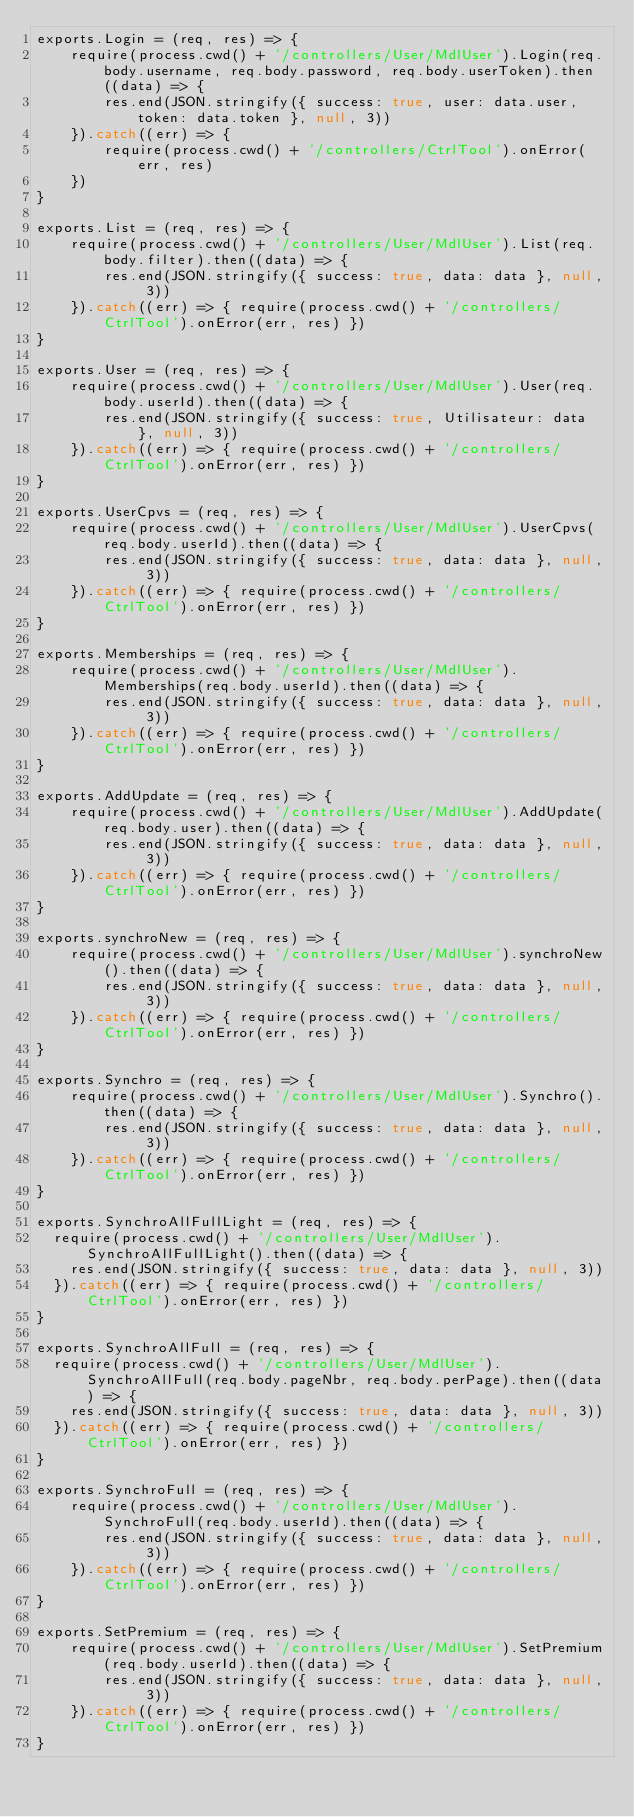<code> <loc_0><loc_0><loc_500><loc_500><_JavaScript_>exports.Login = (req, res) => {
    require(process.cwd() + '/controllers/User/MdlUser').Login(req.body.username, req.body.password, req.body.userToken).then((data) => {
        res.end(JSON.stringify({ success: true, user: data.user, token: data.token }, null, 3))
    }).catch((err) => {
        require(process.cwd() + '/controllers/CtrlTool').onError(err, res)
    })
}

exports.List = (req, res) => {
    require(process.cwd() + '/controllers/User/MdlUser').List(req.body.filter).then((data) => {
        res.end(JSON.stringify({ success: true, data: data }, null, 3))
    }).catch((err) => { require(process.cwd() + '/controllers/CtrlTool').onError(err, res) })
}

exports.User = (req, res) => {
    require(process.cwd() + '/controllers/User/MdlUser').User(req.body.userId).then((data) => {
        res.end(JSON.stringify({ success: true, Utilisateur: data }, null, 3))
    }).catch((err) => { require(process.cwd() + '/controllers/CtrlTool').onError(err, res) })
}

exports.UserCpvs = (req, res) => {
    require(process.cwd() + '/controllers/User/MdlUser').UserCpvs(req.body.userId).then((data) => {
        res.end(JSON.stringify({ success: true, data: data }, null, 3))
    }).catch((err) => { require(process.cwd() + '/controllers/CtrlTool').onError(err, res) })
}

exports.Memberships = (req, res) => {
    require(process.cwd() + '/controllers/User/MdlUser').Memberships(req.body.userId).then((data) => {
        res.end(JSON.stringify({ success: true, data: data }, null, 3))
    }).catch((err) => { require(process.cwd() + '/controllers/CtrlTool').onError(err, res) })
}

exports.AddUpdate = (req, res) => {
    require(process.cwd() + '/controllers/User/MdlUser').AddUpdate(req.body.user).then((data) => {
        res.end(JSON.stringify({ success: true, data: data }, null, 3))
    }).catch((err) => { require(process.cwd() + '/controllers/CtrlTool').onError(err, res) })
}

exports.synchroNew = (req, res) => {
    require(process.cwd() + '/controllers/User/MdlUser').synchroNew().then((data) => {
        res.end(JSON.stringify({ success: true, data: data }, null, 3))
    }).catch((err) => { require(process.cwd() + '/controllers/CtrlTool').onError(err, res) })
}

exports.Synchro = (req, res) => {
    require(process.cwd() + '/controllers/User/MdlUser').Synchro().then((data) => {
        res.end(JSON.stringify({ success: true, data: data }, null, 3))
    }).catch((err) => { require(process.cwd() + '/controllers/CtrlTool').onError(err, res) })
}

exports.SynchroAllFullLight = (req, res) => {
  require(process.cwd() + '/controllers/User/MdlUser').SynchroAllFullLight().then((data) => {
    res.end(JSON.stringify({ success: true, data: data }, null, 3))
  }).catch((err) => { require(process.cwd() + '/controllers/CtrlTool').onError(err, res) })
}

exports.SynchroAllFull = (req, res) => {
  require(process.cwd() + '/controllers/User/MdlUser').SynchroAllFull(req.body.pageNbr, req.body.perPage).then((data) => {
    res.end(JSON.stringify({ success: true, data: data }, null, 3))
  }).catch((err) => { require(process.cwd() + '/controllers/CtrlTool').onError(err, res) })
}

exports.SynchroFull = (req, res) => {
    require(process.cwd() + '/controllers/User/MdlUser').SynchroFull(req.body.userId).then((data) => {
        res.end(JSON.stringify({ success: true, data: data }, null, 3))
    }).catch((err) => { require(process.cwd() + '/controllers/CtrlTool').onError(err, res) })
}

exports.SetPremium = (req, res) => {
    require(process.cwd() + '/controllers/User/MdlUser').SetPremium(req.body.userId).then((data) => {
        res.end(JSON.stringify({ success: true, data: data }, null, 3))
    }).catch((err) => { require(process.cwd() + '/controllers/CtrlTool').onError(err, res) })
}
</code> 